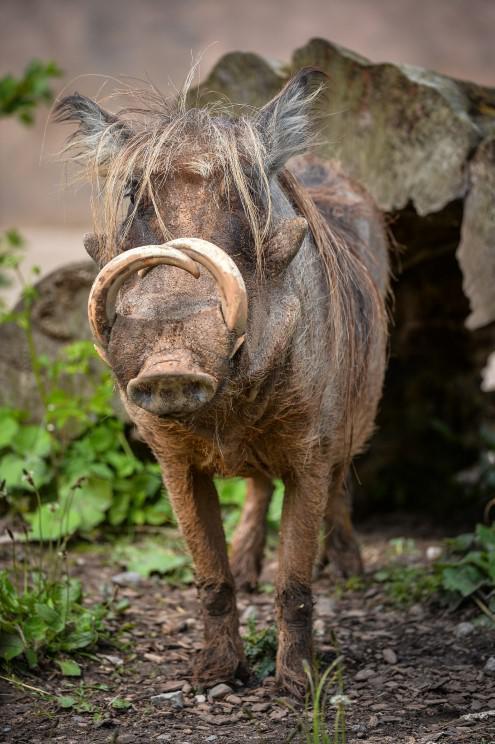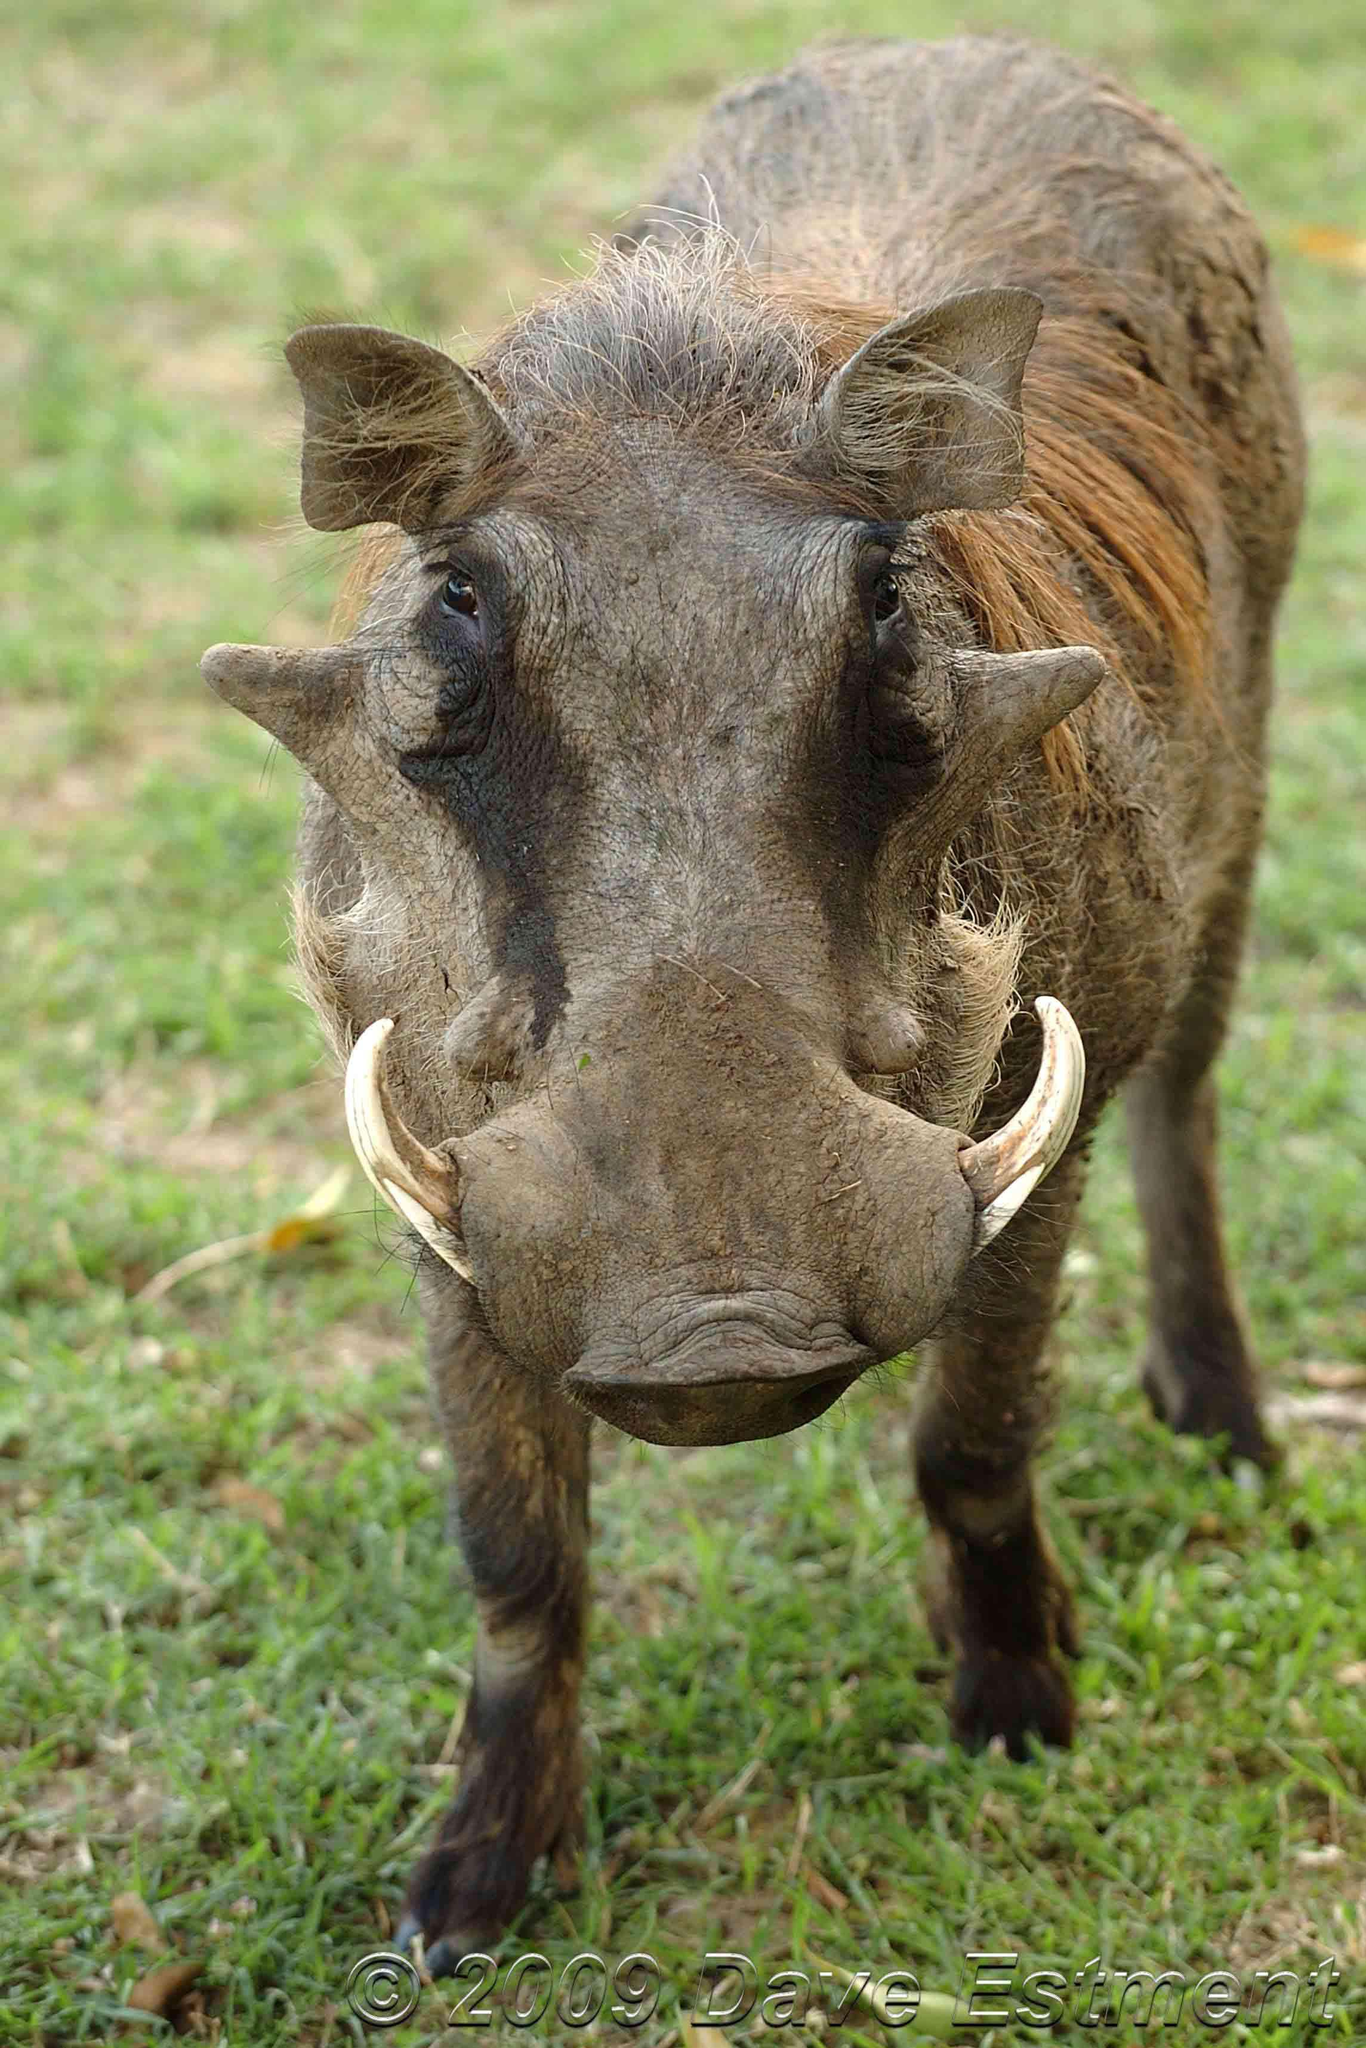The first image is the image on the left, the second image is the image on the right. Assess this claim about the two images: "The animals in the image on the right are eating grass.". Correct or not? Answer yes or no. No. 